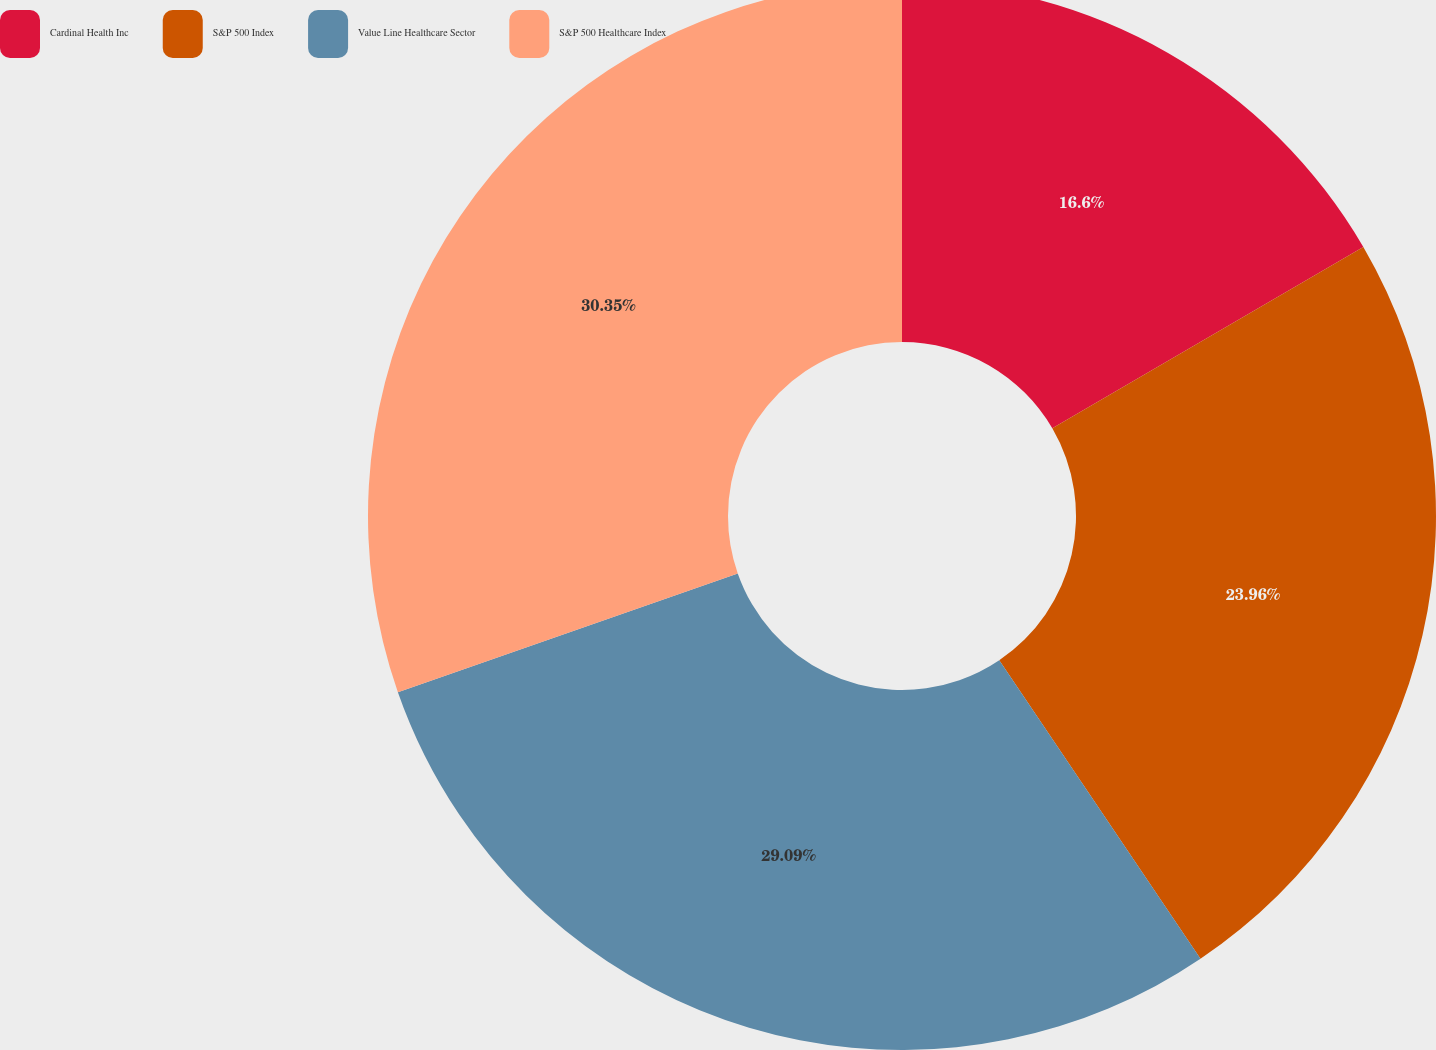<chart> <loc_0><loc_0><loc_500><loc_500><pie_chart><fcel>Cardinal Health Inc<fcel>S&P 500 Index<fcel>Value Line Healthcare Sector<fcel>S&P 500 Healthcare Index<nl><fcel>16.6%<fcel>23.96%<fcel>29.09%<fcel>30.35%<nl></chart> 